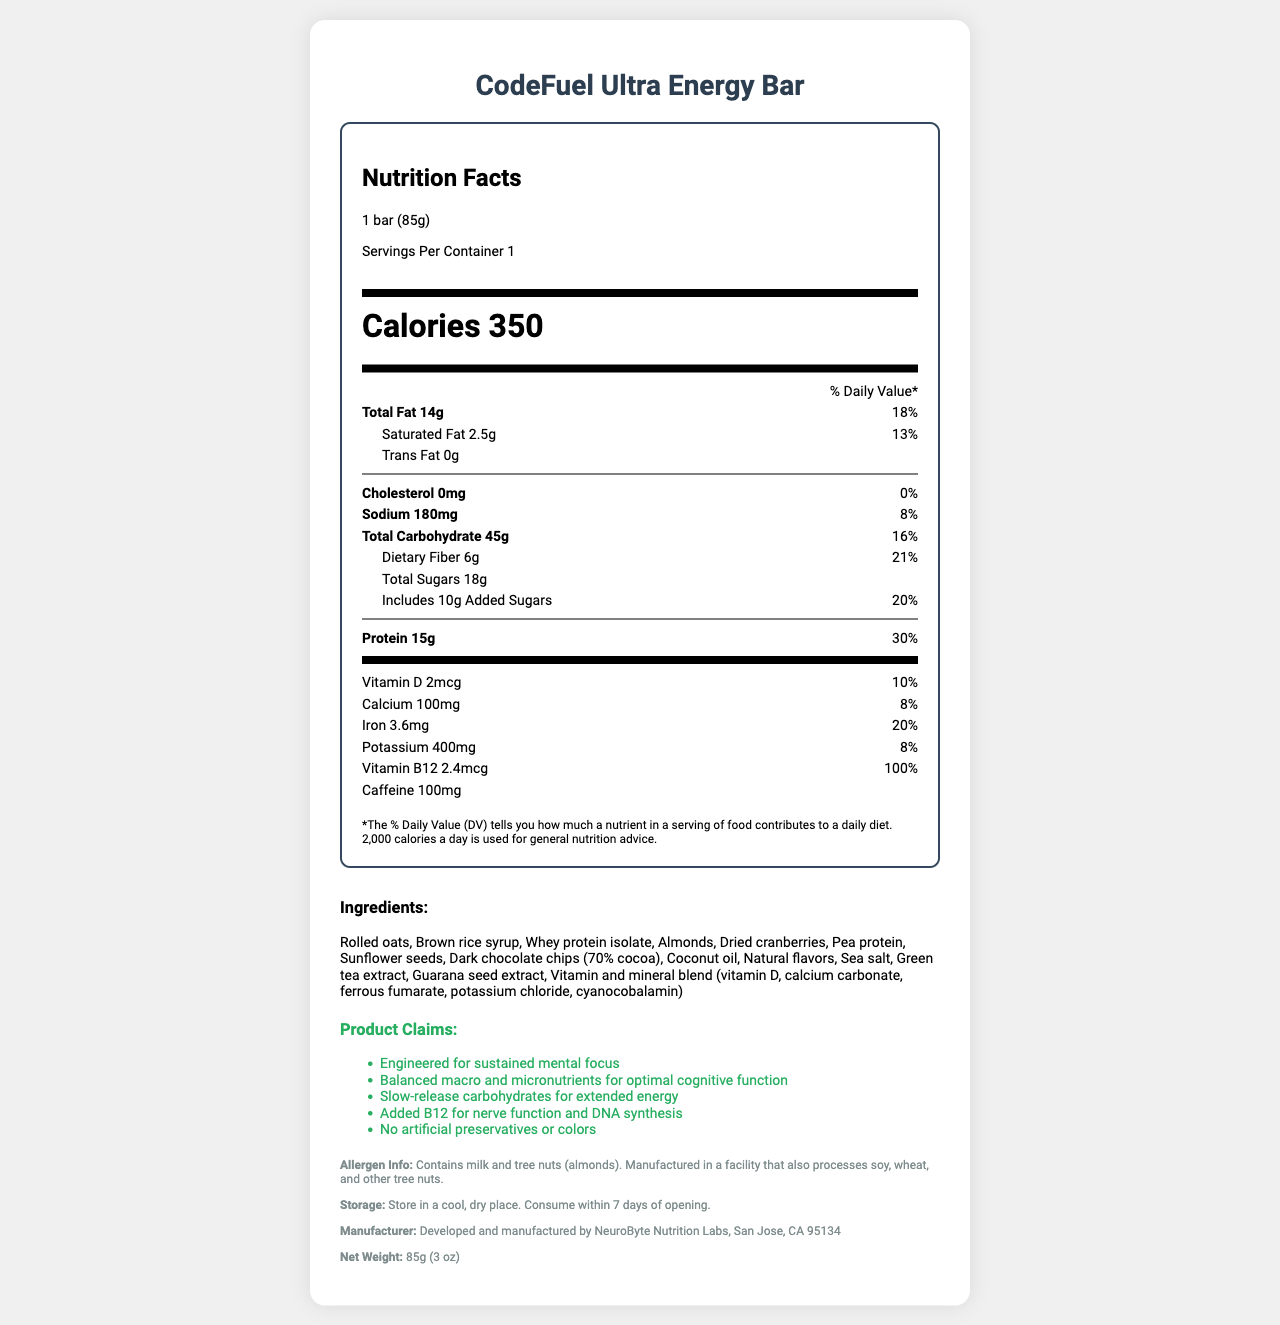what is the serving size of the CodeFuel Ultra Energy Bar? The serving size information is provided in the Serving Info section of the Nutrition Facts Label.
Answer: 1 bar (85g) how much protein does each bar contain? The protein content is listed under the main nutrients in the Nutrition Facts Label.
Answer: 15g what is the percentage of daily value for iron per serving? The percentage of daily value for iron is listed under the micronutrient section of the Nutrition Facts Label.
Answer: 20% mention two ingredients used in the CodeFuel Ultra Energy Bar The list of ingredients is provided under the Ingredients section.
Answer: Rolled oats, Whey protein isolate how many calories does one bar provide? The calorie content is prominently displayed under the Calories section of the Nutrition Facts Label.
Answer: 350 which of the following is NOT a claim made by the product? A. Supports weight loss B. Balanced macro and micronutrients for optimal cognitive function C. Added B12 for nerve function and DNA synthesis The listed claims are found under the Product Claims section and "Supports weight loss" is not mentioned.
Answer: A. Supports weight loss what is the serving size of the CodeFuel Ultra Energy Bar in grams? A. 70g B. 85g C. 100g D. 50g The serving size is specified as 1 bar (85g) in the Serving Info section.
Answer: B. 85g does the product contain any added sugars? The added sugars content is provided in the Total Sugars section and further specified as 10g of Added Sugars.
Answer: Yes is the bar manufactured by NeuroByte Nutrition Labs? The Manufacturer Info states that the product is developed and manufactured by NeuroByte Nutrition Labs, San Jose, CA 95134.
Answer: Yes summarize the document by describing its main idea The document provides comprehensive information about the CodeFuel Ultra Energy Bar, including nutrition facts, ingredients, benefits, and manufacturing details, aiming to inform consumers about its suitability for sustained mental focus during prolonged coding activities.
Answer: This document is a nutrition facts label for the "CodeFuel Ultra Energy Bar", detailing its nutritional content, ingredients, product claims, allergen information, and manufacturer details. The bar is designed for long coding sessions and emphasizes balanced macro and micronutrients, slow-release carbohydrates, and added vitamin B12 for cognitive function. what is the specific percentage of daily value for saturated fat? The daily value percentage for saturated fat is listed under the Fat section in the Nutrition Facts Label.
Answer: 13% what are the two sources of caffeine included in the energy bar? The sources of caffeine are specified in the Ingredients List as Green tea extract and Guarana seed extract.
Answer: Green tea extract, Guarana seed extract how much fiber does the bar contain? The dietary fiber content is provided under the main nutrients in the Nutrition Facts Label.
Answer: 6g how many total carbohydrates are present in one bar? The total carbohydrate content is listed under the main nutrients in the Nutrition Facts Label.
Answer: 45g how long should the bar be consumed after opening? The storage instructions specify that the bar should be consumed within 7 days of opening.
Answer: Within 7 days does the product meet the daily requirement for vitamin B12? The document states that the bar provides 100% of the daily value for vitamin B12.
Answer: Yes is the CodeFuel Ultra Energy Bar free from tree nuts? The allergen info mentions that the bar contains milk and tree nuts (almonds).
Answer: No what is the total fat content of the bar based on a daily diet of 2,000 calories? The total fat percentage of daily value is provided as 18%, based on a daily diet of 2,000 calories.
Answer: 18% determine the specific amount of calcium present in the bar The calcium content is listed under the micronutrient section in the Nutrition Facts Label.
Answer: 100mg who is the primary target audience for this energy bar? The visual information in the document does not provide a clear indication of the primary target audience for the energy bar.
Answer: Cannot be determined 